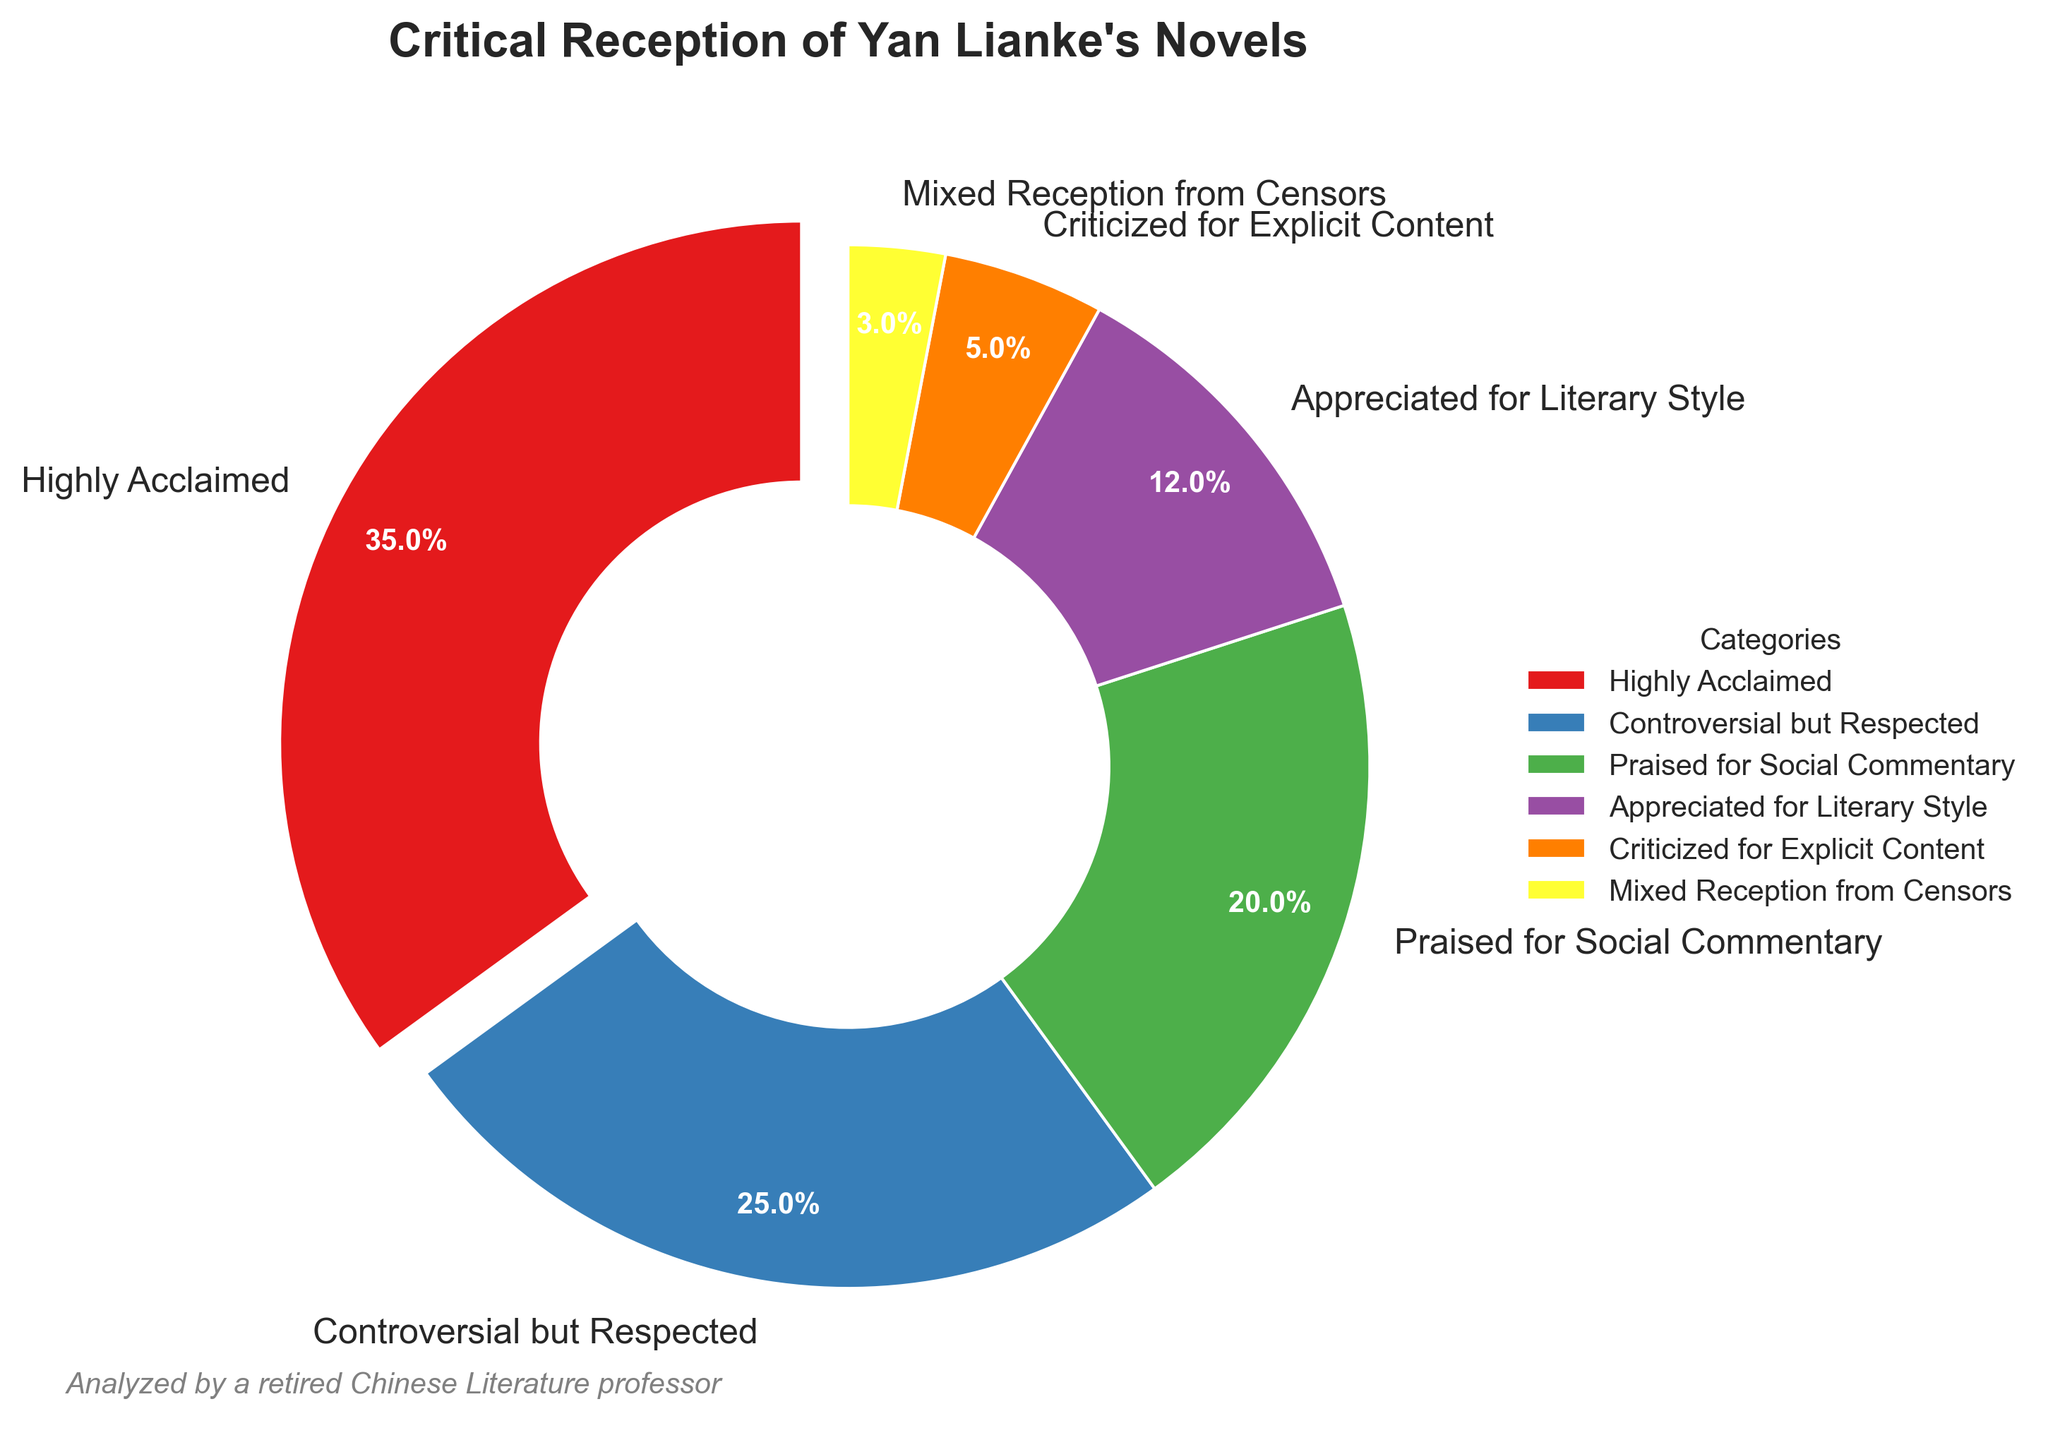What category has received the highest percentage of critical reception? The category with the highest percentage of critical reception is identified by the largest wedge in the pie chart, which is labeled "Highly Acclaimed" with 35%.
Answer: Highly Acclaimed Which two categories combined make up more than half of the total critical reception percentages? Summing the percentages of "Highly Acclaimed" (35%) and "Controversial but Respected" (25%) yields 60%, which is more than 50% of the total.
Answer: Highly Acclaimed and Controversial but Respected How much less is the "Criticized for Explicit Content" category compared to the "Praised for Social Commentary" category? The percentage for "Praised for Social Commentary" is 20%, and for "Criticized for Explicit Content" it is 5%. The difference is calculated as 20% - 5% = 15%.
Answer: 15% Which category has the smallest wedge size in the pie chart? The smallest wedge in the pie chart is labeled "Mixed Reception from Censors" with 3%.
Answer: Mixed Reception from Censors What is the combined percentage of categories that received less than 10% critical reception? The categories below 10% are "Criticized for Explicit Content" (5%) and "Mixed Reception from Censors" (3%). Adding these yields 5% + 3% = 8%.
Answer: 8% Compare the "Appreciated for Literary Style" category to the "Praised for Social Commentary" category in terms of percentage. Which is greater and by how much? "Praised for Social Commentary" has 20% and "Appreciated for Literary Style" has 12%. The difference is 20% - 12% = 8%. The "Praised for Social Commentary" category is greater by 8%.
Answer: Praised for Social Commentary by 8% If we combine the percentages for "Controversial but Respected" and "Appreciated for Literary Style", how does their total compare to the "Highly Acclaimed" category? Combining "Controversial but Respected" (25%) and "Appreciated for Literary Style" (12%) gives 25% + 12% = 37%. This is 2% more than "Highly Acclaimed" at 35%.
Answer: Combined total is 2% greater What color is associated with the "Praised for Social Commentary" category? The wedge for "Praised for Social Commentary" is colored in green.
Answer: Green 